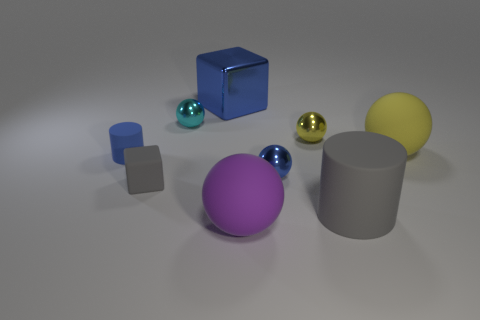What material is the tiny blue thing that is on the right side of the large purple matte object?
Provide a short and direct response. Metal. Is the number of large blue blocks less than the number of tiny cyan matte objects?
Keep it short and to the point. No. Is the number of small shiny objects that are behind the tiny blue cylinder greater than the number of large blue blocks to the right of the large rubber cylinder?
Ensure brevity in your answer.  Yes. Does the large gray cylinder have the same material as the large purple thing?
Ensure brevity in your answer.  Yes. What number of large spheres are behind the gray object to the right of the cyan shiny thing?
Ensure brevity in your answer.  1. There is a large object that is behind the tiny cyan metallic object; is its color the same as the small cylinder?
Your answer should be compact. Yes. What number of objects are tiny rubber objects or blocks that are left of the big blue shiny thing?
Provide a short and direct response. 2. Does the tiny thing that is behind the small yellow object have the same shape as the blue metal object on the left side of the purple rubber object?
Give a very brief answer. No. Is there any other thing that is the same color as the tiny block?
Ensure brevity in your answer.  Yes. What shape is the blue object that is the same material as the purple ball?
Your answer should be compact. Cylinder. 